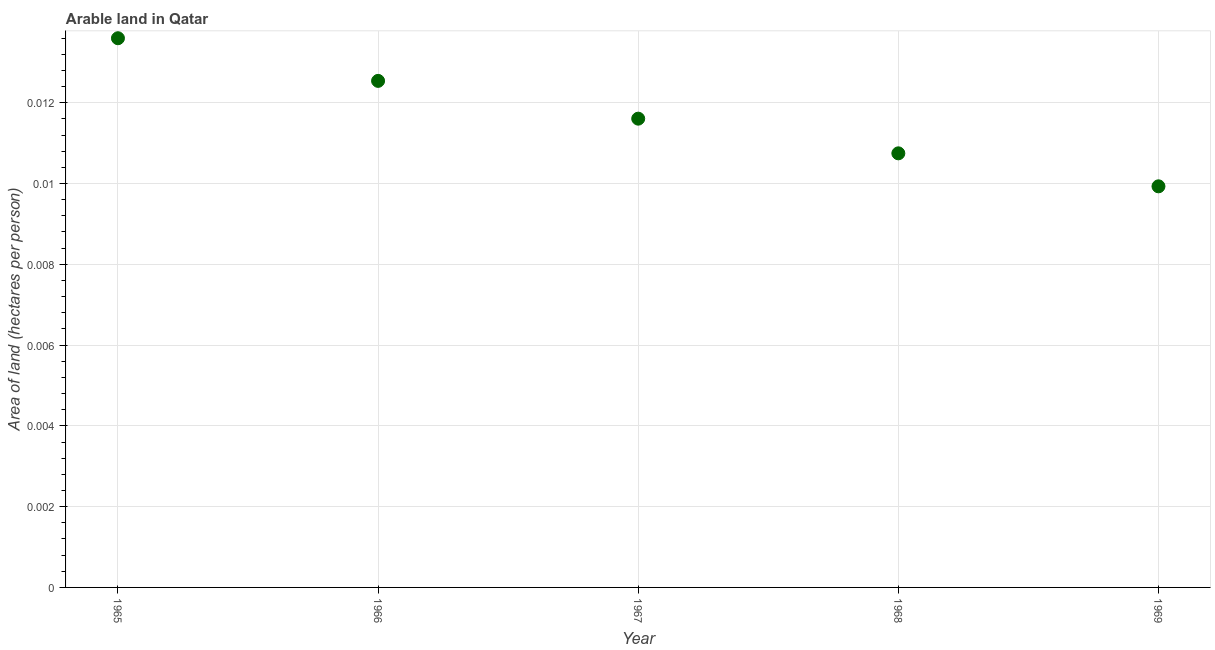What is the area of arable land in 1965?
Your answer should be very brief. 0.01. Across all years, what is the maximum area of arable land?
Provide a short and direct response. 0.01. Across all years, what is the minimum area of arable land?
Provide a succinct answer. 0.01. In which year was the area of arable land maximum?
Your response must be concise. 1965. In which year was the area of arable land minimum?
Keep it short and to the point. 1969. What is the sum of the area of arable land?
Keep it short and to the point. 0.06. What is the difference between the area of arable land in 1967 and 1969?
Offer a very short reply. 0. What is the average area of arable land per year?
Offer a very short reply. 0.01. What is the median area of arable land?
Provide a short and direct response. 0.01. Do a majority of the years between 1967 and 1969 (inclusive) have area of arable land greater than 0.0044 hectares per person?
Make the answer very short. Yes. What is the ratio of the area of arable land in 1965 to that in 1969?
Provide a short and direct response. 1.37. Is the area of arable land in 1966 less than that in 1968?
Offer a terse response. No. What is the difference between the highest and the second highest area of arable land?
Your answer should be very brief. 0. Is the sum of the area of arable land in 1966 and 1969 greater than the maximum area of arable land across all years?
Ensure brevity in your answer.  Yes. What is the difference between the highest and the lowest area of arable land?
Your answer should be compact. 0. In how many years, is the area of arable land greater than the average area of arable land taken over all years?
Make the answer very short. 2. Does the area of arable land monotonically increase over the years?
Offer a very short reply. No. How many dotlines are there?
Ensure brevity in your answer.  1. What is the difference between two consecutive major ticks on the Y-axis?
Ensure brevity in your answer.  0. Does the graph contain any zero values?
Offer a very short reply. No. Does the graph contain grids?
Your answer should be compact. Yes. What is the title of the graph?
Offer a terse response. Arable land in Qatar. What is the label or title of the Y-axis?
Make the answer very short. Area of land (hectares per person). What is the Area of land (hectares per person) in 1965?
Your answer should be very brief. 0.01. What is the Area of land (hectares per person) in 1966?
Make the answer very short. 0.01. What is the Area of land (hectares per person) in 1967?
Give a very brief answer. 0.01. What is the Area of land (hectares per person) in 1968?
Provide a succinct answer. 0.01. What is the Area of land (hectares per person) in 1969?
Your response must be concise. 0.01. What is the difference between the Area of land (hectares per person) in 1965 and 1966?
Provide a succinct answer. 0. What is the difference between the Area of land (hectares per person) in 1965 and 1967?
Your answer should be compact. 0. What is the difference between the Area of land (hectares per person) in 1965 and 1968?
Your answer should be compact. 0. What is the difference between the Area of land (hectares per person) in 1965 and 1969?
Your answer should be compact. 0. What is the difference between the Area of land (hectares per person) in 1966 and 1967?
Provide a short and direct response. 0. What is the difference between the Area of land (hectares per person) in 1966 and 1968?
Ensure brevity in your answer.  0. What is the difference between the Area of land (hectares per person) in 1966 and 1969?
Your answer should be compact. 0. What is the difference between the Area of land (hectares per person) in 1967 and 1968?
Provide a succinct answer. 0. What is the difference between the Area of land (hectares per person) in 1967 and 1969?
Keep it short and to the point. 0. What is the difference between the Area of land (hectares per person) in 1968 and 1969?
Provide a succinct answer. 0. What is the ratio of the Area of land (hectares per person) in 1965 to that in 1966?
Offer a terse response. 1.08. What is the ratio of the Area of land (hectares per person) in 1965 to that in 1967?
Your answer should be compact. 1.17. What is the ratio of the Area of land (hectares per person) in 1965 to that in 1968?
Offer a terse response. 1.26. What is the ratio of the Area of land (hectares per person) in 1965 to that in 1969?
Provide a succinct answer. 1.37. What is the ratio of the Area of land (hectares per person) in 1966 to that in 1967?
Provide a succinct answer. 1.08. What is the ratio of the Area of land (hectares per person) in 1966 to that in 1968?
Provide a succinct answer. 1.17. What is the ratio of the Area of land (hectares per person) in 1966 to that in 1969?
Your response must be concise. 1.26. What is the ratio of the Area of land (hectares per person) in 1967 to that in 1969?
Give a very brief answer. 1.17. What is the ratio of the Area of land (hectares per person) in 1968 to that in 1969?
Provide a short and direct response. 1.08. 